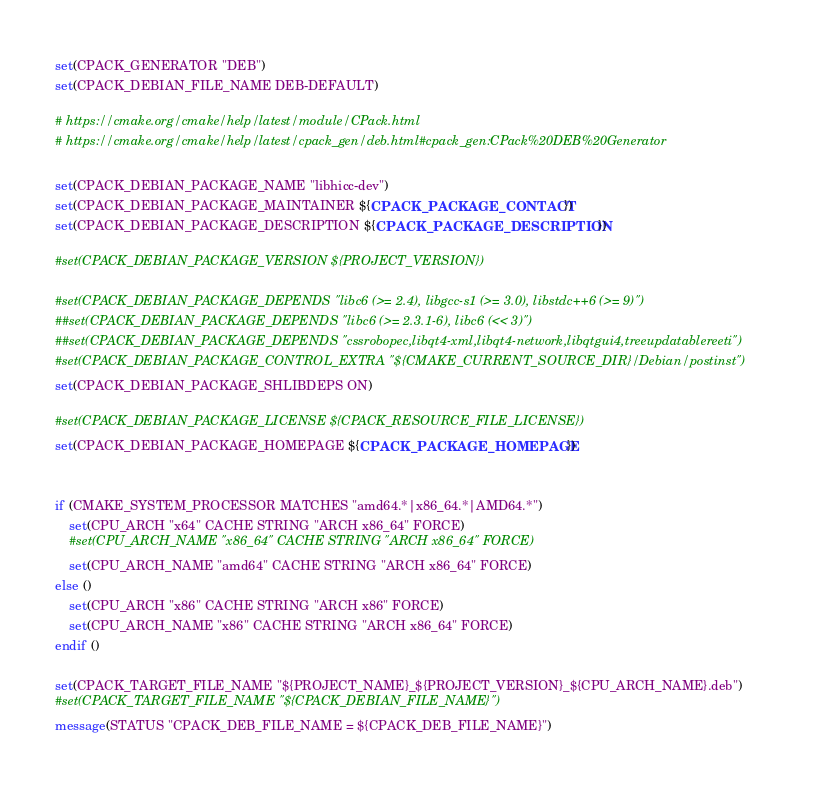Convert code to text. <code><loc_0><loc_0><loc_500><loc_500><_CMake_>set(CPACK_GENERATOR "DEB")
set(CPACK_DEBIAN_FILE_NAME DEB-DEFAULT)

# https://cmake.org/cmake/help/latest/module/CPack.html
# https://cmake.org/cmake/help/latest/cpack_gen/deb.html#cpack_gen:CPack%20DEB%20Generator

set(CPACK_DEBIAN_PACKAGE_NAME "libhicc-dev")
set(CPACK_DEBIAN_PACKAGE_MAINTAINER ${CPACK_PACKAGE_CONTACT})
set(CPACK_DEBIAN_PACKAGE_DESCRIPTION ${CPACK_PACKAGE_DESCRIPTION})

#set(CPACK_DEBIAN_PACKAGE_VERSION ${PROJECT_VERSION})

#set(CPACK_DEBIAN_PACKAGE_DEPENDS "libc6 (>= 2.4), libgcc-s1 (>= 3.0), libstdc++6 (>= 9)")
##set(CPACK_DEBIAN_PACKAGE_DEPENDS "libc6 (>= 2.3.1-6), libc6 (<< 3)")
##set(CPACK_DEBIAN_PACKAGE_DEPENDS "cssrobopec,libqt4-xml,libqt4-network,libqtgui4,treeupdatablereeti")
#set(CPACK_DEBIAN_PACKAGE_CONTROL_EXTRA "${CMAKE_CURRENT_SOURCE_DIR}/Debian/postinst")
set(CPACK_DEBIAN_PACKAGE_SHLIBDEPS ON)

#set(CPACK_DEBIAN_PACKAGE_LICENSE ${CPACK_RESOURCE_FILE_LICENSE})
set(CPACK_DEBIAN_PACKAGE_HOMEPAGE ${CPACK_PACKAGE_HOMEPAGE})


if (CMAKE_SYSTEM_PROCESSOR MATCHES "amd64.*|x86_64.*|AMD64.*")
    set(CPU_ARCH "x64" CACHE STRING "ARCH x86_64" FORCE)
    #set(CPU_ARCH_NAME "x86_64" CACHE STRING "ARCH x86_64" FORCE)
    set(CPU_ARCH_NAME "amd64" CACHE STRING "ARCH x86_64" FORCE)
else ()
    set(CPU_ARCH "x86" CACHE STRING "ARCH x86" FORCE)
    set(CPU_ARCH_NAME "x86" CACHE STRING "ARCH x86_64" FORCE)
endif ()

set(CPACK_TARGET_FILE_NAME "${PROJECT_NAME}_${PROJECT_VERSION}_${CPU_ARCH_NAME}.deb")
#set(CPACK_TARGET_FILE_NAME "${CPACK_DEBIAN_FILE_NAME}")
message(STATUS "CPACK_DEB_FILE_NAME = ${CPACK_DEB_FILE_NAME}")
</code> 